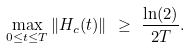<formula> <loc_0><loc_0><loc_500><loc_500>\max _ { 0 \leq t \leq T } \| H _ { c } ( t ) \| \ \geq \ \frac { \ln ( 2 ) } { 2 T } .</formula> 